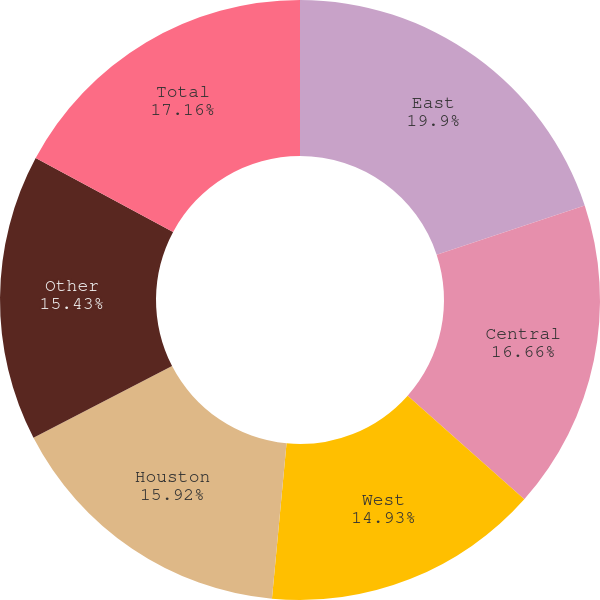Convert chart. <chart><loc_0><loc_0><loc_500><loc_500><pie_chart><fcel>East<fcel>Central<fcel>West<fcel>Houston<fcel>Other<fcel>Total<nl><fcel>19.9%<fcel>16.66%<fcel>14.93%<fcel>15.92%<fcel>15.43%<fcel>17.16%<nl></chart> 